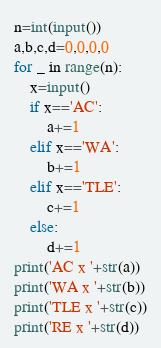Convert code to text. <code><loc_0><loc_0><loc_500><loc_500><_Python_>n=int(input())
a,b,c,d=0,0,0,0
for _ in range(n):
    x=input()
    if x=='AC':
        a+=1
    elif x=='WA':
        b+=1
    elif x=='TLE':
        c+=1
    else:
        d+=1
print('AC x '+str(a))
print('WA x '+str(b))
print('TLE x '+str(c))
print('RE x '+str(d))</code> 